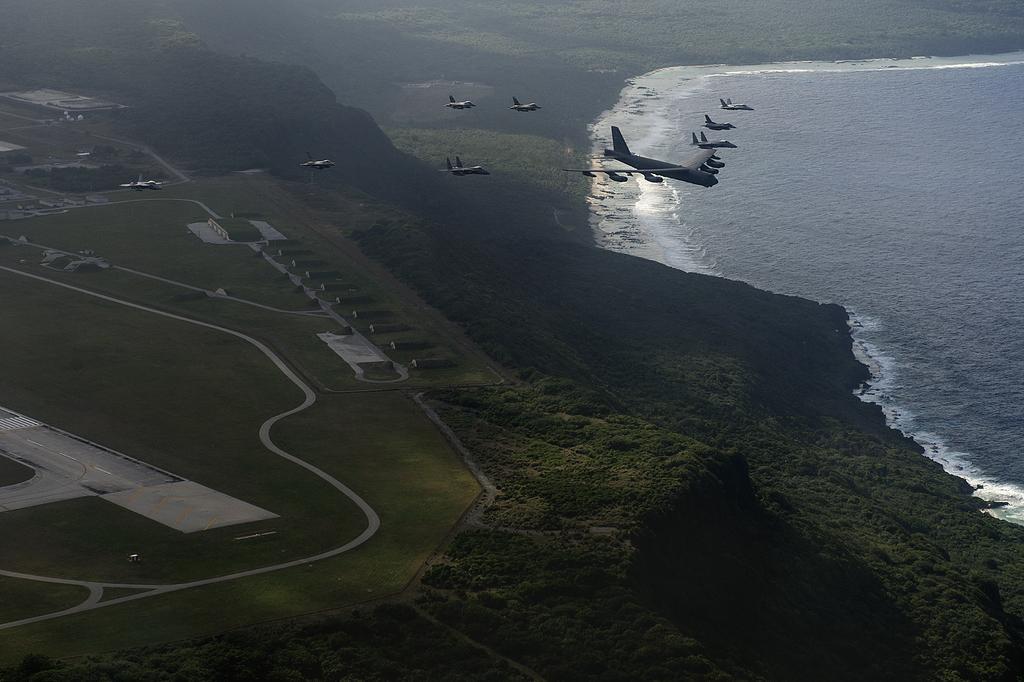Please provide a concise description of this image. Here in this picture we can see number of jet planes and airplanes flying in the air over there and below them on the ground we can see grass present all over there and we can see water on the right side present all over there. 